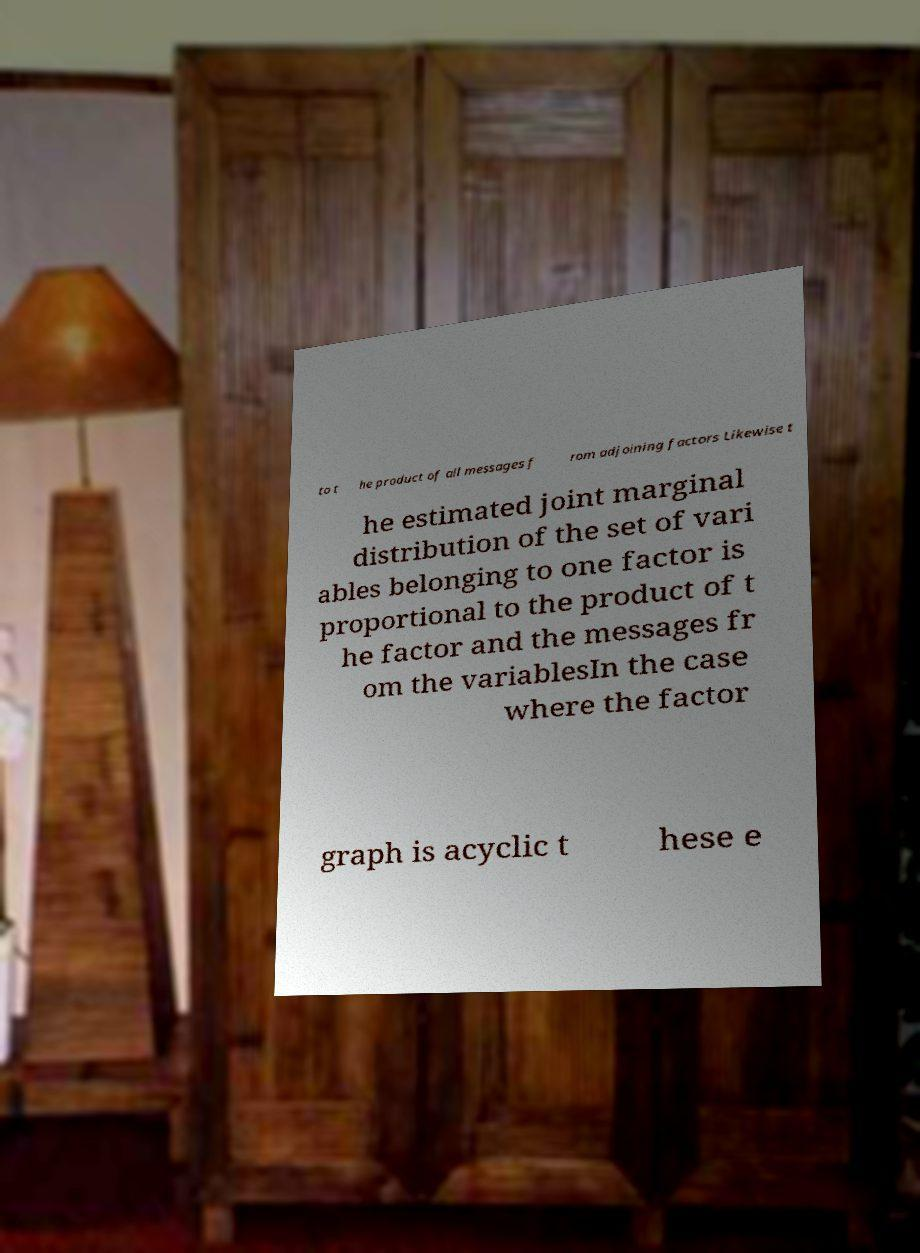For documentation purposes, I need the text within this image transcribed. Could you provide that? to t he product of all messages f rom adjoining factors Likewise t he estimated joint marginal distribution of the set of vari ables belonging to one factor is proportional to the product of t he factor and the messages fr om the variablesIn the case where the factor graph is acyclic t hese e 